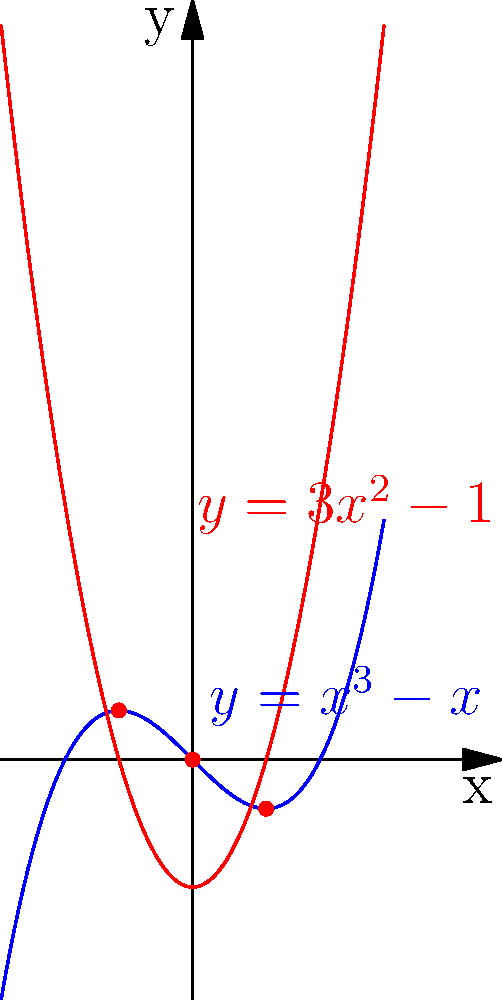In the study of singularities in algebraic varieties, consider the curve $y = x^3 - x$. At which points does this curve have singularities, and what is the geometric interpretation of these points in relation to the curve $y = 3x^2 - 1$? To find the singularities and understand their geometric interpretation, we follow these steps:

1) Singularities occur where both $\frac{dy}{dx} = 0$ and $\frac{d^2y}{dx^2} = 0$.

2) For $y = x^3 - x$:
   $\frac{dy}{dx} = 3x^2 - 1$
   $\frac{d^2y}{dx^2} = 6x$

3) Setting $\frac{dy}{dx} = 0$:
   $3x^2 - 1 = 0$
   $x = \pm \frac{1}{\sqrt{3}}$ and $x = 0$

4) At $x = \pm \frac{1}{\sqrt{3}}$, $\frac{d^2y}{dx^2} \neq 0$, so these are not singularities.

5) At $x = 0$, $\frac{d^2y}{dx^2} = 0$, so this is a singularity.

6) The curve $y = 3x^2 - 1$ is actually the derivative of $y = x^3 - x$.

7) Geometrically, the singularity at (0,0) is where the original curve intersects its derivative curve.

8) The other two intersection points of $y = x^3 - x$ and $y = 3x^2 - 1$ at $x = \pm \frac{1}{\sqrt{3}}$ represent the local extrema of the original curve.
Answer: Singularity at (0,0); intersections with derivative curve 